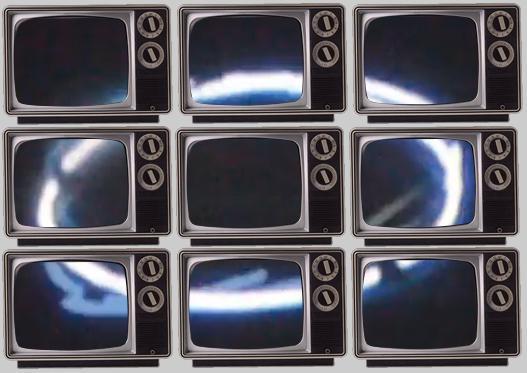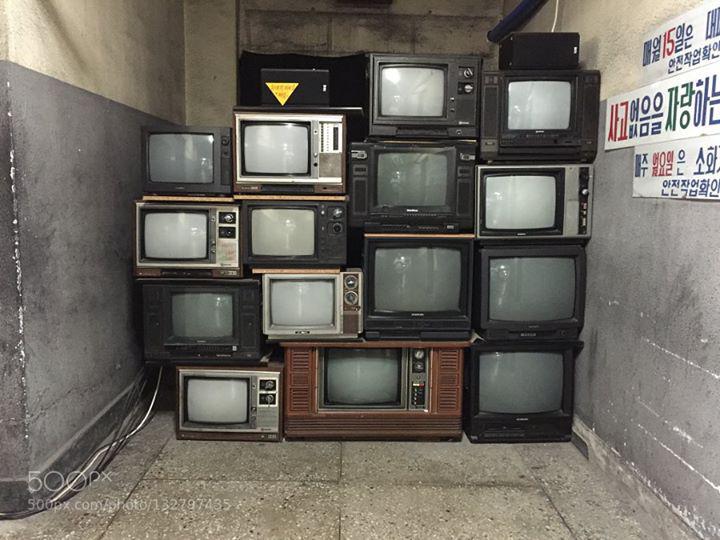The first image is the image on the left, the second image is the image on the right. Examine the images to the left and right. Is the description "There are nine identical TVs placed on each other with exactly two circle knobs on the right hand side of each of the nine televisions." accurate? Answer yes or no. Yes. The first image is the image on the left, the second image is the image on the right. For the images shown, is this caption "There are three stacks of  televisions stacked three high next to each other." true? Answer yes or no. Yes. 